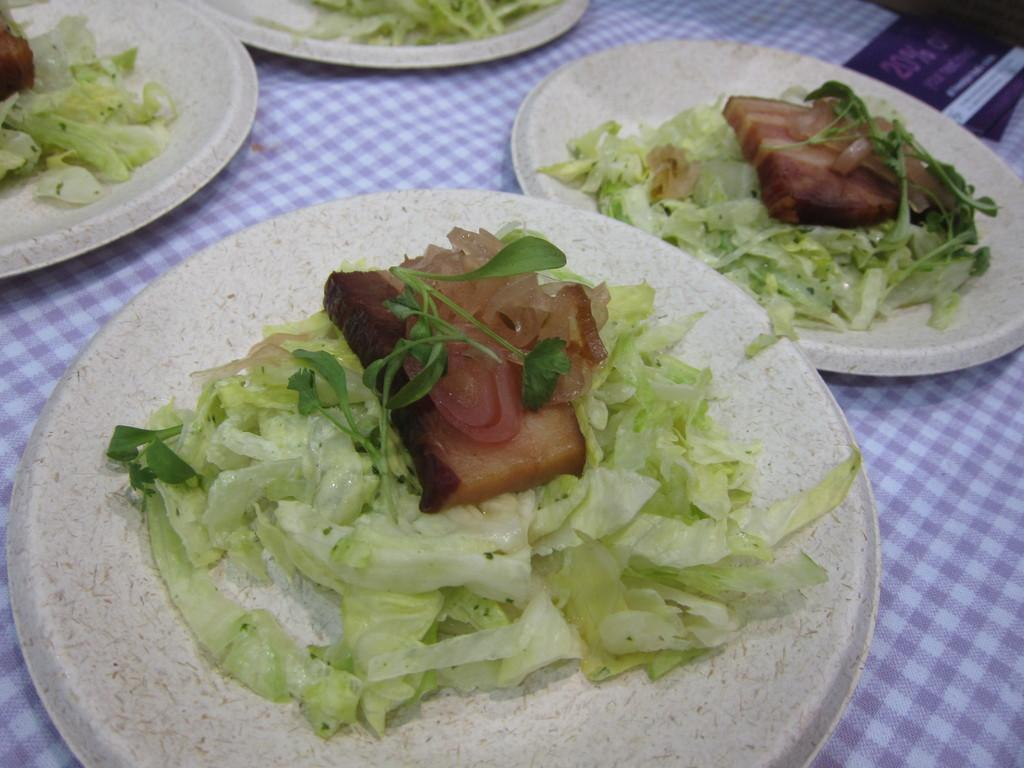What is on the plates that are visible in the image? There are foods on plates in the image. Where are the plates with food located? The plates are on a table. How is the table positioned in the image? The table is in the center of the image. Are there any fairies dancing around the plates of food in the image? There are no fairies present in the image. What type of corn is being served on the plates in the image? There is no corn visible on the plates in the image. 